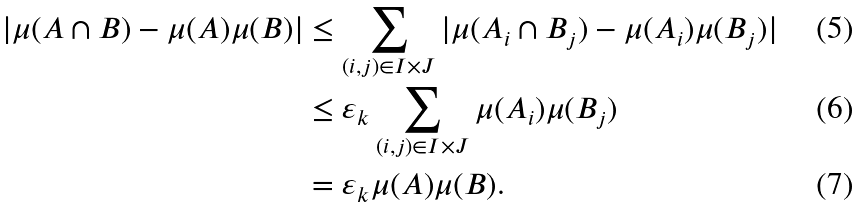<formula> <loc_0><loc_0><loc_500><loc_500>| \mu ( A \cap B ) - \mu ( A ) \mu ( B ) | & \leq \sum _ { ( i , j ) \in I \times J } | \mu ( A _ { i } \cap B _ { j } ) - \mu ( A _ { i } ) \mu ( B _ { j } ) | \\ & \leq \varepsilon _ { k } \sum _ { ( i , j ) \in I \times J } \mu ( A _ { i } ) \mu ( B _ { j } ) \\ & = \varepsilon _ { k } \mu ( A ) \mu ( B ) .</formula> 